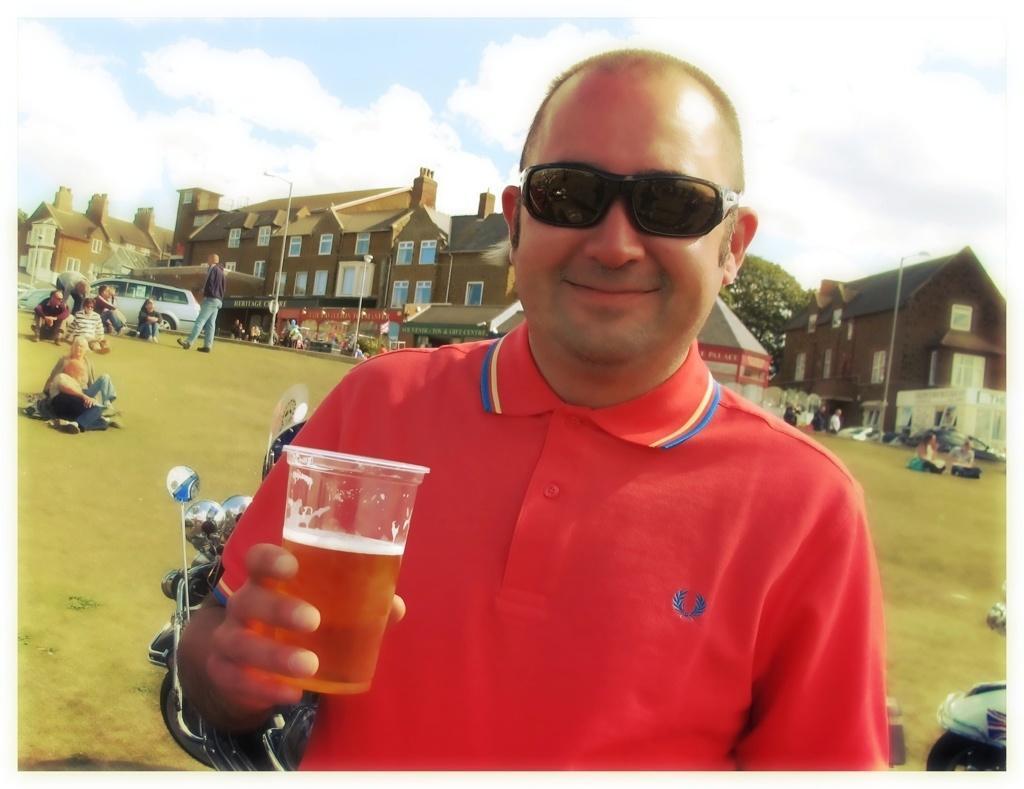How would you summarize this image in a sentence or two? In this picture we can see man standing and smiling and holding glass in his hand and in background we can see buildings, some more persons, car, pole, sky with clouds, trees. 